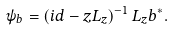<formula> <loc_0><loc_0><loc_500><loc_500>\psi _ { b } = \left ( i d - z L _ { z } \right ) ^ { - 1 } L _ { z } b ^ { \ast } .</formula> 